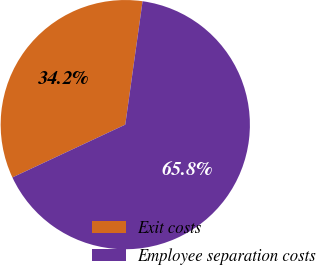Convert chart. <chart><loc_0><loc_0><loc_500><loc_500><pie_chart><fcel>Exit costs<fcel>Employee separation costs<nl><fcel>34.18%<fcel>65.82%<nl></chart> 